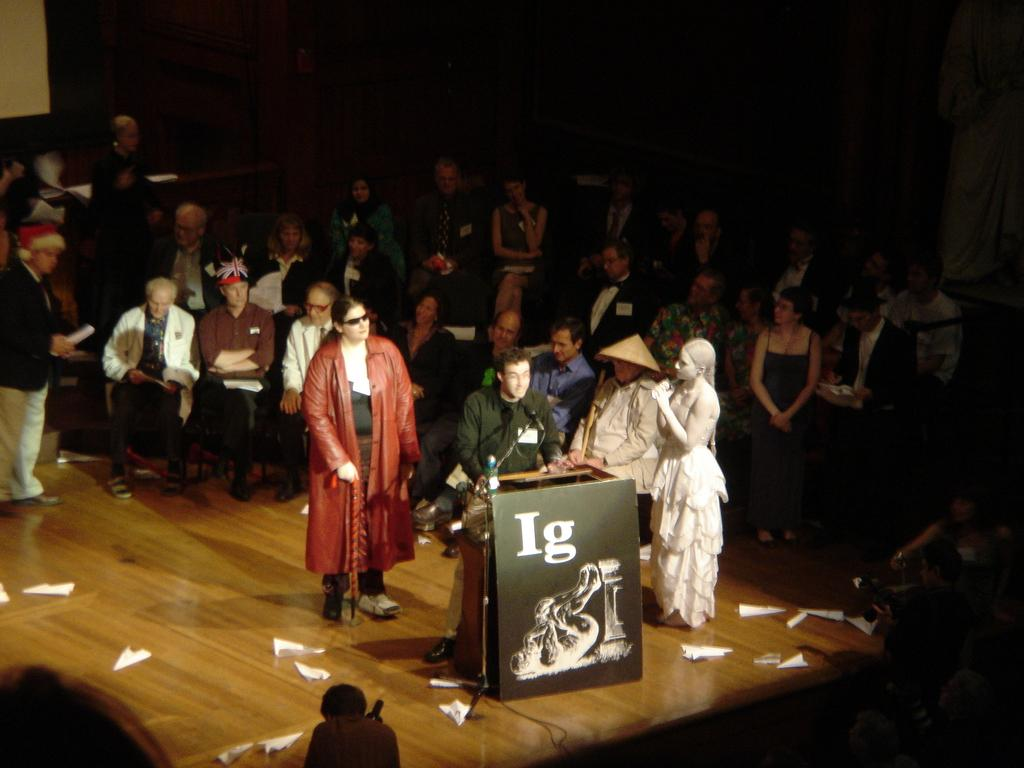What is the crow doing in the foreground of the image? The crow is sitting on chairs in the foreground of the image. Can you describe the people in the image? There are people standing in the image. Where do you think the image might have been taken? The image appears to be taken in a hall. What is the crow writing on the chairs in the image? There is no indication that the crow is writing on the chairs in the image. 